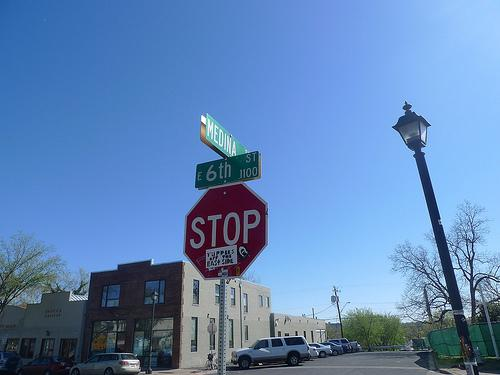Question: how many lamp posts are there?
Choices:
A. 5.
B. 2.
C. 9.
D. 1.
Answer with the letter. Answer: D Question: what is left of the street?
Choices:
A. Buildings.
B. A bus.
C. Trucks.
D. Cars.
Answer with the letter. Answer: A Question: why are cars parked?
Choices:
A. Drivers are at work.
B. It's lunch time.
C. The drivers are in the stores.
D. Drivers are at the restaurant.
Answer with the letter. Answer: C Question: what color is the stop sign?
Choices:
A. Gray.
B. White.
C. Yellow.
D. Red.
Answer with the letter. Answer: D 